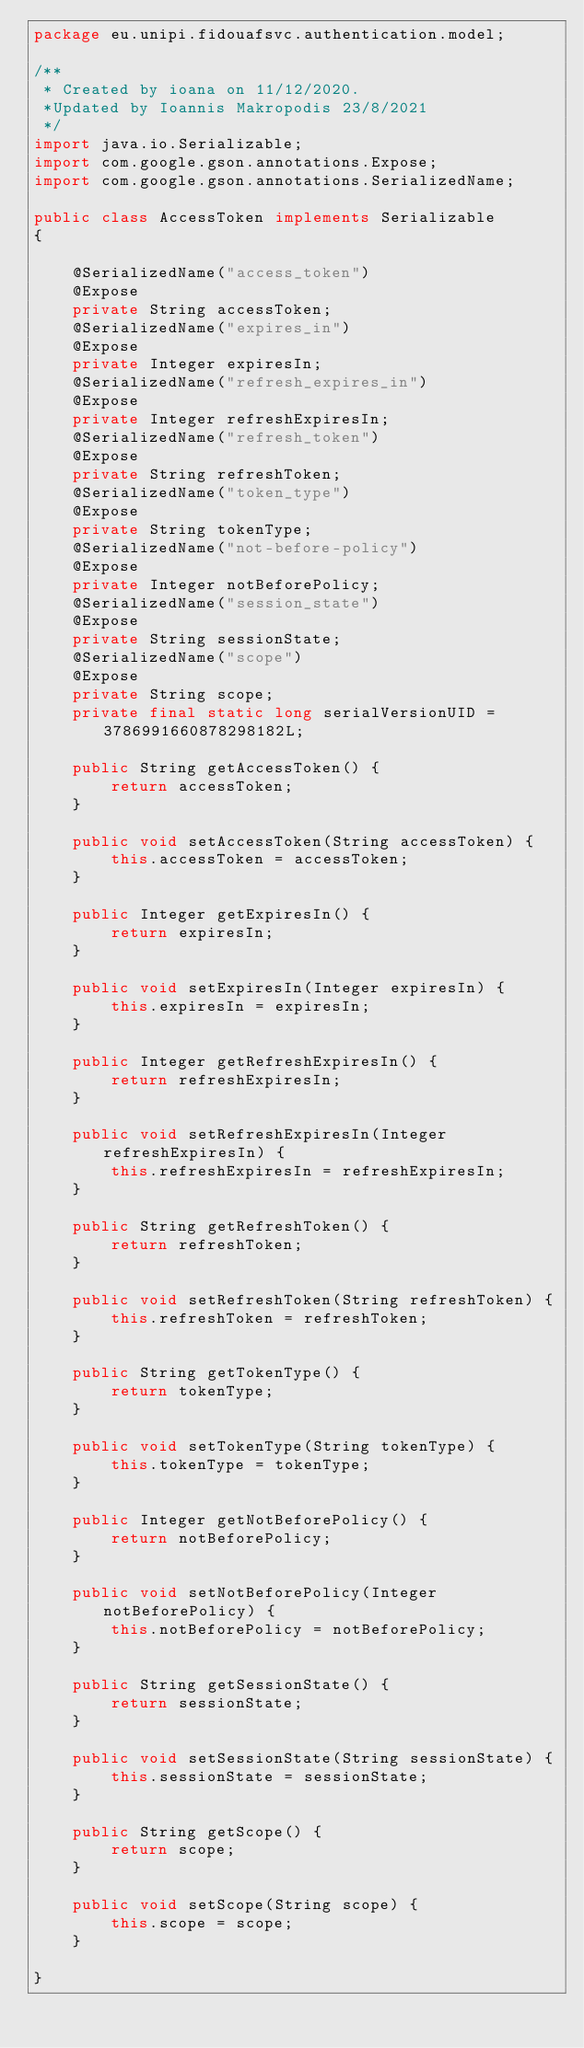<code> <loc_0><loc_0><loc_500><loc_500><_Java_>package eu.unipi.fidouafsvc.authentication.model;

/**
 * Created by ioana on 11/12/2020.
 *Updated by Ioannis Makropodis 23/8/2021
 */
import java.io.Serializable;
import com.google.gson.annotations.Expose;
import com.google.gson.annotations.SerializedName;

public class AccessToken implements Serializable
{

    @SerializedName("access_token")
    @Expose
    private String accessToken;
    @SerializedName("expires_in")
    @Expose
    private Integer expiresIn;
    @SerializedName("refresh_expires_in")
    @Expose
    private Integer refreshExpiresIn;
    @SerializedName("refresh_token")
    @Expose
    private String refreshToken;
    @SerializedName("token_type")
    @Expose
    private String tokenType;
    @SerializedName("not-before-policy")
    @Expose
    private Integer notBeforePolicy;
    @SerializedName("session_state")
    @Expose
    private String sessionState;
    @SerializedName("scope")
    @Expose
    private String scope;
    private final static long serialVersionUID = 3786991660878298182L;

    public String getAccessToken() {
        return accessToken;
    }

    public void setAccessToken(String accessToken) {
        this.accessToken = accessToken;
    }

    public Integer getExpiresIn() {
        return expiresIn;
    }

    public void setExpiresIn(Integer expiresIn) {
        this.expiresIn = expiresIn;
    }

    public Integer getRefreshExpiresIn() {
        return refreshExpiresIn;
    }

    public void setRefreshExpiresIn(Integer refreshExpiresIn) {
        this.refreshExpiresIn = refreshExpiresIn;
    }

    public String getRefreshToken() {
        return refreshToken;
    }

    public void setRefreshToken(String refreshToken) {
        this.refreshToken = refreshToken;
    }

    public String getTokenType() {
        return tokenType;
    }

    public void setTokenType(String tokenType) {
        this.tokenType = tokenType;
    }

    public Integer getNotBeforePolicy() {
        return notBeforePolicy;
    }

    public void setNotBeforePolicy(Integer notBeforePolicy) {
        this.notBeforePolicy = notBeforePolicy;
    }

    public String getSessionState() {
        return sessionState;
    }

    public void setSessionState(String sessionState) {
        this.sessionState = sessionState;
    }

    public String getScope() {
        return scope;
    }

    public void setScope(String scope) {
        this.scope = scope;
    }

}
</code> 